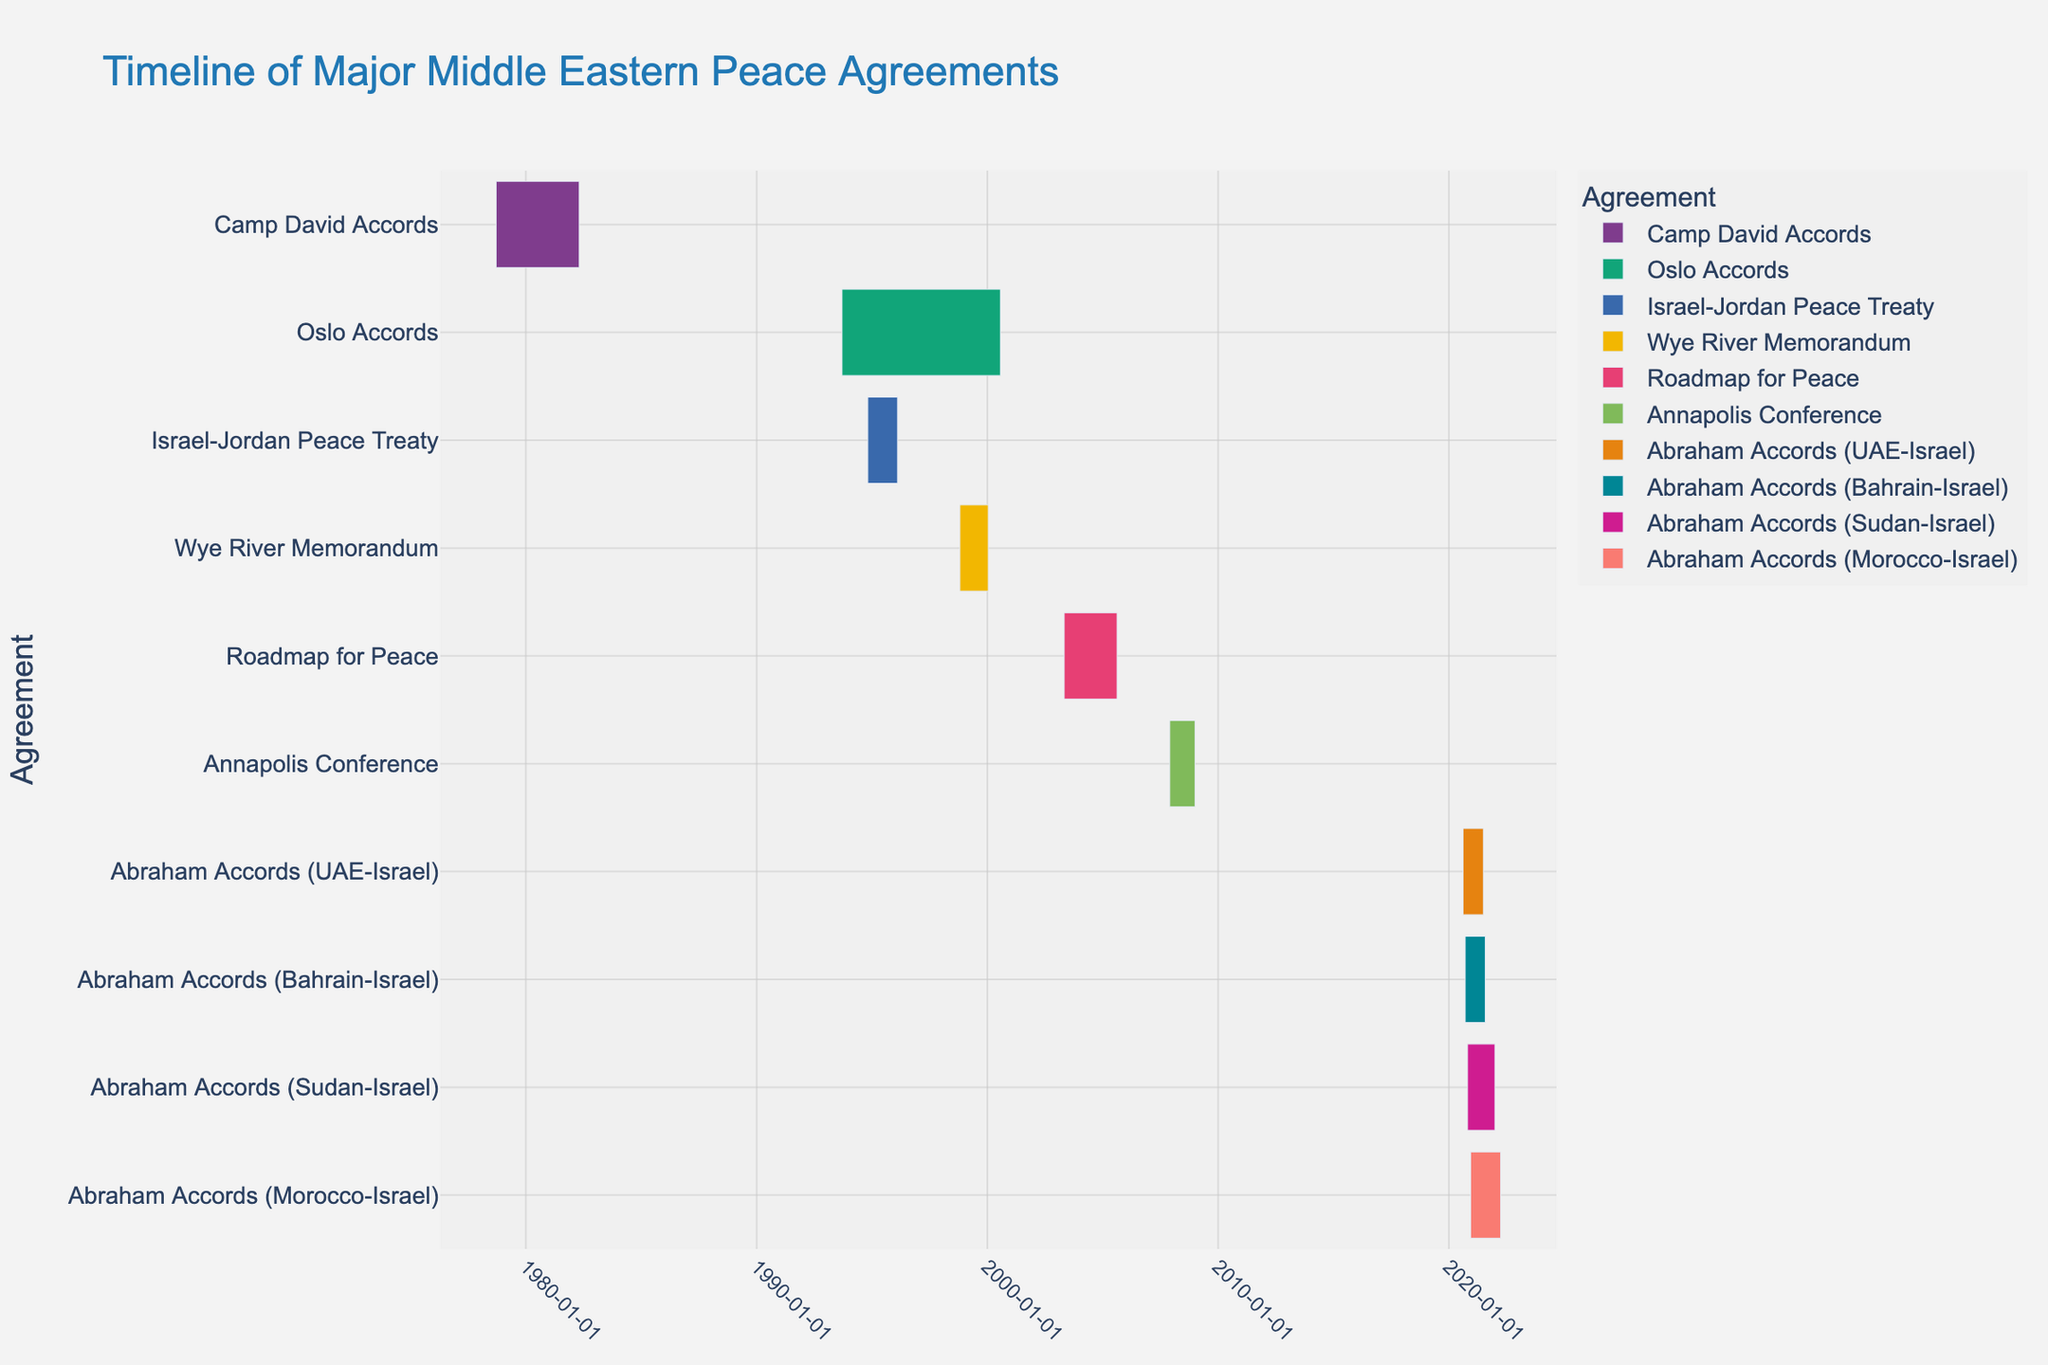What is the title of the Gantt chart? The title of the chart is located at the top center of the figure and typically describes the main topic or data being presented. "Timeline of Major Middle Eastern Peace Agreements" is visible in the title area of the plot.
Answer: Timeline of Major Middle Eastern Peace Agreements Which peace agreement has the longest implementation phase? To find this, we need to compare the duration of each bar on the Gantt chart. The bar with the longest horizontal span represents the longest implementation phase. On visual inspection, the "Camp David Accords" (from 1978-09-17 to 1982-04-25) spans the most time.
Answer: Camp David Accords Which peace agreement concluded first chronologically? To determine this, look for the earliest end date on the x-axis. The "Camp David Accords" concluded on 1982-04-25, which is the earliest end date among the agreements listed.
Answer: Camp David Accords How many peace agreements are represented in the Gantt chart? Count the number of unique tasks or bars on the Gantt chart. Each task represents a peace agreement. There are ten different agreements shown.
Answer: 10 Which implementation phase started most recently? The most recent start date will be towards the rightmost end of the x-axis. The "Abraham Accords (Morocco-Israel)" started on 2020-12-10, the latest start date in the dataset.
Answer: Abraham Accords (Morocco-Israel) How does the duration of the "Oslo Accords" compare to the "Israel-Jordan Peace Treaty"? Check the duration of both agreements. "Oslo Accords" spans from 1993-09-13 to 2000-07-25, which is longer than the "Israel-Jordan Peace Treaty" spanning from 1994-10-26 to 1996-02-10.
Answer: Oslo Accords is longer What is the total duration of implementation for all Abraham Accords combined? Sum the duration of all bars labeled as "Abraham Accords." "Abraham Accords (UAE-Israel)" is 322 days, "Abraham Accords (Bahrain-Israel)" is 320 days, "Abraham Accords (Sudan-Israel)" is 434 days, and "Abraham Accords (Morocco-Israel)" is 476 days. The total is 322 + 320 + 434 + 476 = 1552 days.
Answer: 1552 days Which agreement had a shorter implementation phase, the “Annapolis Conference” or the “Wye River Memorandum”? Compare the duration by inspecting the time span of the bars. "Annapolis Conference" spans from 2007-11-27 to 2008-12-31, while "Wye River Memorandum" spans from 1998-10-23 to 2000-01-15. "Annapolis Conference" has a shorter span.
Answer: Annapolis Conference Which agreements overlap in their implementation phases? Identify bars that intersect on the timeline. The "Oslo Accords" (1993-09-13 to 2000-07-25) and the "Israel-Jordan Peace Treaty" (1994-10-26 to 1996-02-10), as well as other combinations such as "Wye River Memorandum" and "Oslo Accords," have overlapping durations.
Answer: Oslo Accords and Israel-Jordan Peace Treaty, Wye River Memorandum and Oslo Accords 